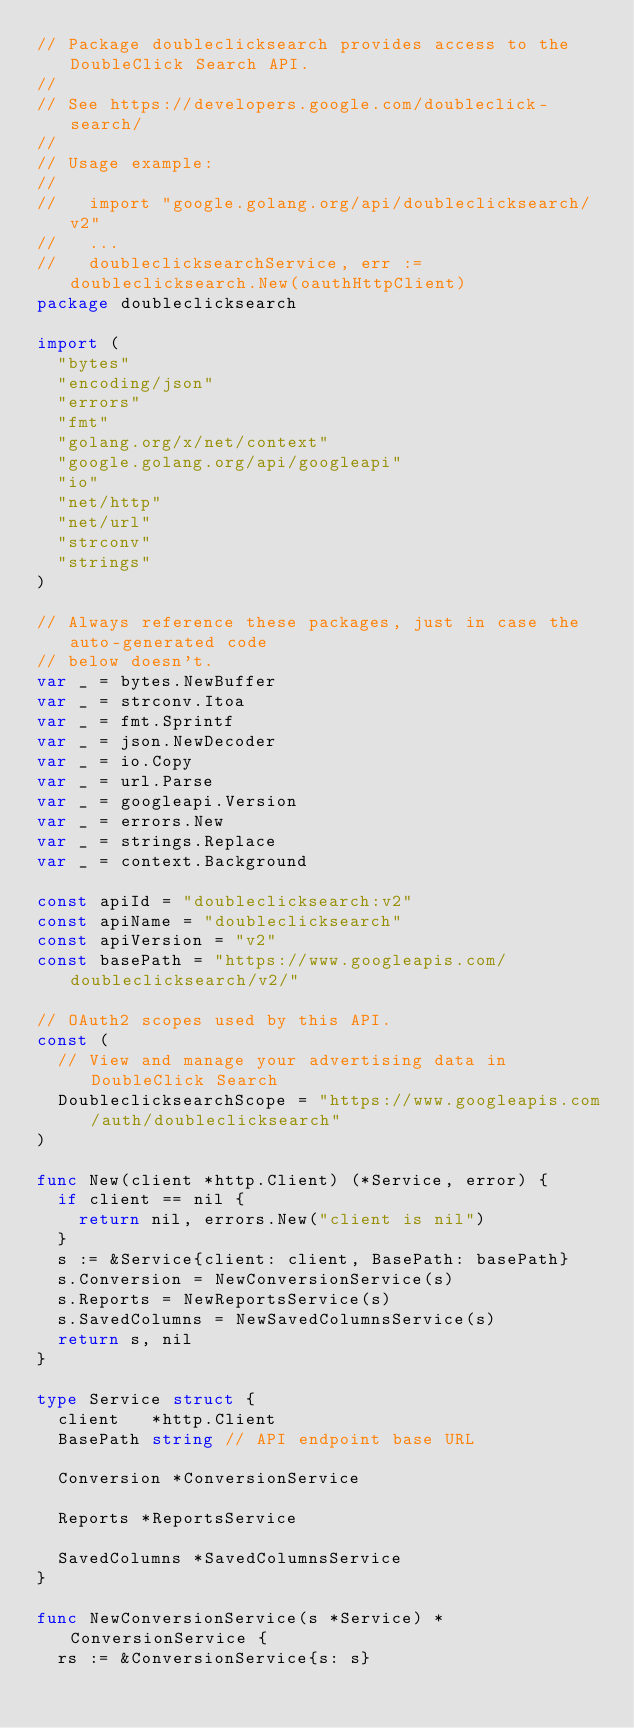<code> <loc_0><loc_0><loc_500><loc_500><_Go_>// Package doubleclicksearch provides access to the DoubleClick Search API.
//
// See https://developers.google.com/doubleclick-search/
//
// Usage example:
//
//   import "google.golang.org/api/doubleclicksearch/v2"
//   ...
//   doubleclicksearchService, err := doubleclicksearch.New(oauthHttpClient)
package doubleclicksearch

import (
	"bytes"
	"encoding/json"
	"errors"
	"fmt"
	"golang.org/x/net/context"
	"google.golang.org/api/googleapi"
	"io"
	"net/http"
	"net/url"
	"strconv"
	"strings"
)

// Always reference these packages, just in case the auto-generated code
// below doesn't.
var _ = bytes.NewBuffer
var _ = strconv.Itoa
var _ = fmt.Sprintf
var _ = json.NewDecoder
var _ = io.Copy
var _ = url.Parse
var _ = googleapi.Version
var _ = errors.New
var _ = strings.Replace
var _ = context.Background

const apiId = "doubleclicksearch:v2"
const apiName = "doubleclicksearch"
const apiVersion = "v2"
const basePath = "https://www.googleapis.com/doubleclicksearch/v2/"

// OAuth2 scopes used by this API.
const (
	// View and manage your advertising data in DoubleClick Search
	DoubleclicksearchScope = "https://www.googleapis.com/auth/doubleclicksearch"
)

func New(client *http.Client) (*Service, error) {
	if client == nil {
		return nil, errors.New("client is nil")
	}
	s := &Service{client: client, BasePath: basePath}
	s.Conversion = NewConversionService(s)
	s.Reports = NewReportsService(s)
	s.SavedColumns = NewSavedColumnsService(s)
	return s, nil
}

type Service struct {
	client   *http.Client
	BasePath string // API endpoint base URL

	Conversion *ConversionService

	Reports *ReportsService

	SavedColumns *SavedColumnsService
}

func NewConversionService(s *Service) *ConversionService {
	rs := &ConversionService{s: s}</code> 